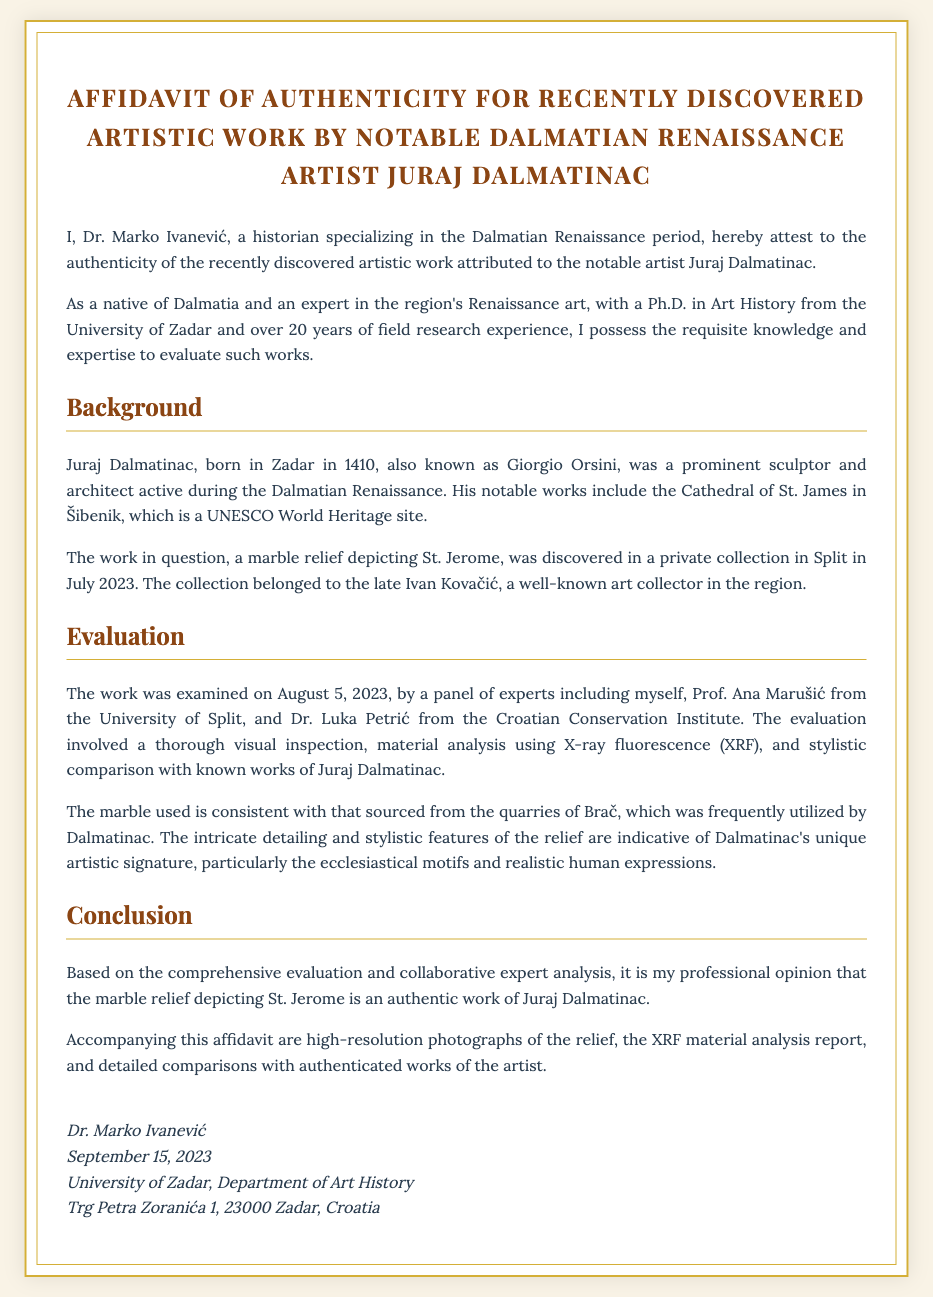What is the title of the affidavit? The title of the affidavit is stated prominently at the top of the document, which reads "Affidavit of Authenticity for Recently Discovered Artistic Work by Notable Dalmatian Renaissance Artist Juraj Dalmatinac."
Answer: Affidavit of Authenticity for Recently Discovered Artistic Work by Notable Dalmatian Renaissance Artist Juraj Dalmatinac Who is the affiant? The name of the affiant is mentioned in the opening paragraph as "Dr. Marko Ivanević."
Answer: Dr. Marko Ivanević What is the date of the affidavit? The date when the affidavit was signed is provided in the signature section, indicating "September 15, 2023."
Answer: September 15, 2023 Where was the work discovered? The document states that the work was discovered in a private collection in "Split."
Answer: Split What is the name of the artist attributed to the artwork? The artwork is attributed to the artist named "Juraj Dalmatinac."
Answer: Juraj Dalmatinac What was the medium of the discovered artwork? The document describes the discovered artwork as a "marble relief."
Answer: marble relief What type of analysis was used to evaluate the work? The document mentions the use of "X-ray fluorescence (XRF)" for material analysis.
Answer: X-ray fluorescence (XRF) What is one of Dalmatinac's notable works? The affidavit notes that one of Dalmatinac's notable works includes the "Cathedral of St. James in Šibenik."
Answer: Cathedral of St. James in Šibenik Which institution does Dr. Marko Ivanević represent? The signature section reveals that Dr. Marko Ivanević is from the "University of Zadar, Department of Art History."
Answer: University of Zadar, Department of Art History 